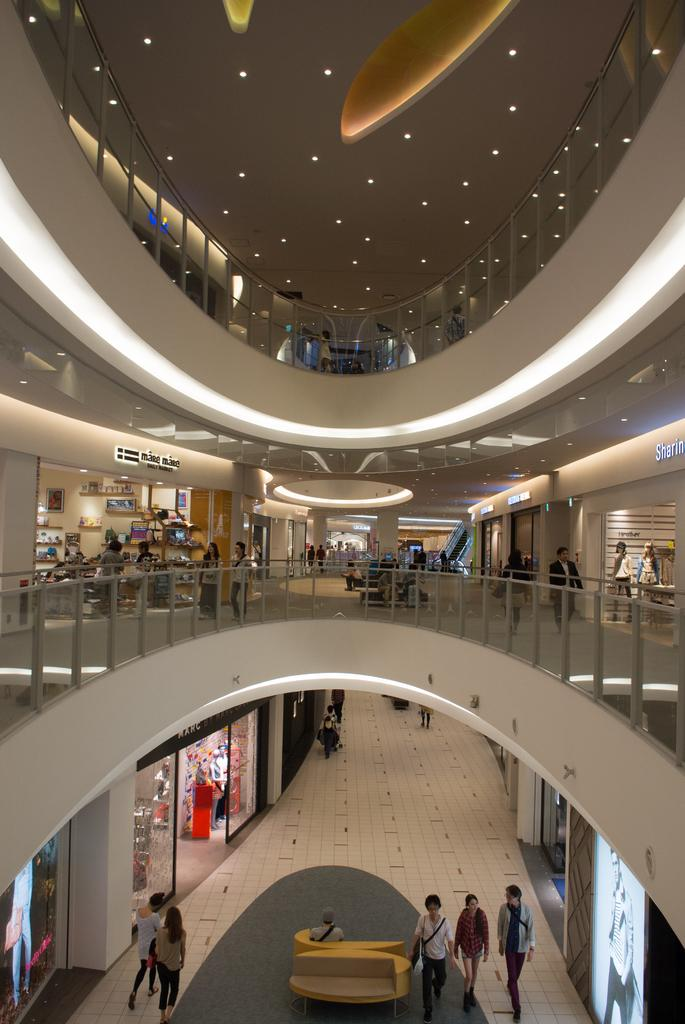What part of a building is shown in the image? The image shows the inner part of a building. What are the people in the image doing? There is a group of people walking on the floor. What can be seen in the background of the image? There are stalls and lights visible in the background. What type of can is being used by the people in the image? There is no can present in the image; it shows a group of people walking on the floor in the inner part of a building. 